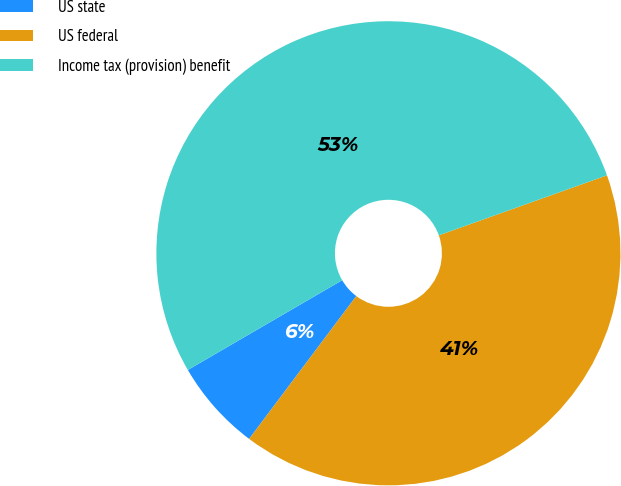<chart> <loc_0><loc_0><loc_500><loc_500><pie_chart><fcel>US state<fcel>US federal<fcel>Income tax (provision) benefit<nl><fcel>6.37%<fcel>40.7%<fcel>52.93%<nl></chart> 